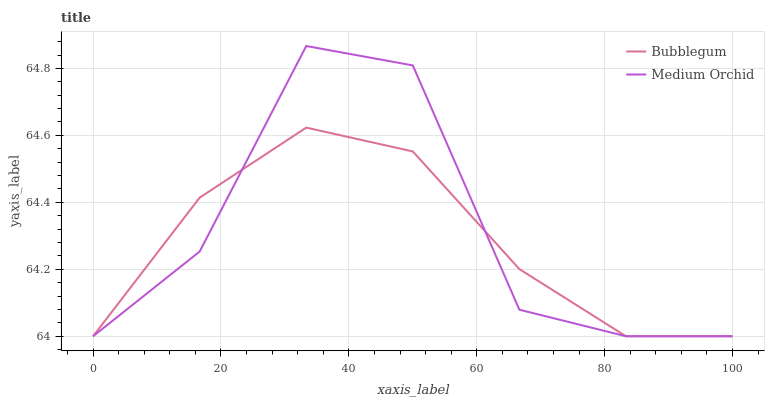Does Bubblegum have the maximum area under the curve?
Answer yes or no. No. Is Bubblegum the roughest?
Answer yes or no. No. Does Bubblegum have the highest value?
Answer yes or no. No. 